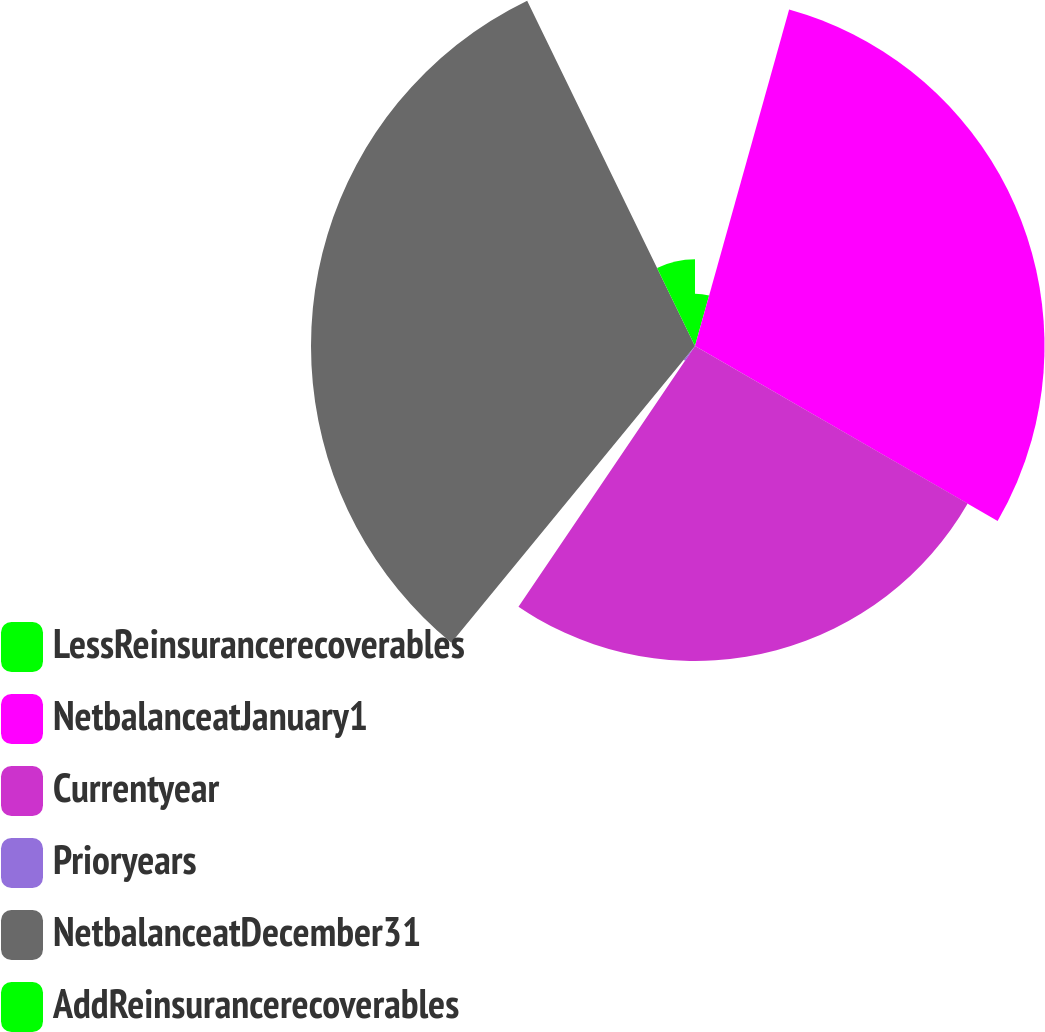Convert chart to OTSL. <chart><loc_0><loc_0><loc_500><loc_500><pie_chart><fcel>LessReinsurancerecoverables<fcel>NetbalanceatJanuary1<fcel>Currentyear<fcel>Prioryears<fcel>NetbalanceatDecember31<fcel>AddReinsurancerecoverables<nl><fcel>4.34%<fcel>29.0%<fcel>26.13%<fcel>1.47%<fcel>31.86%<fcel>7.2%<nl></chart> 